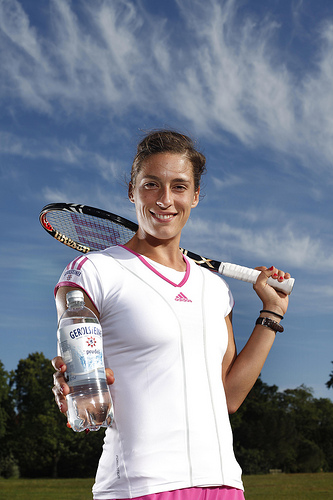Describe the outfit the person is wearing. The person is wearing a white sports shirt with a pink Adidas logo and stripes, along with what appears to be a matching pink sports skirt. The attire is appropriate for athletic endeavors, specifically tennis.  Can you comment on the type of water bottle the person is holding? The water bottle in the person's hand is clear, filled with water, and has a label that seems to indicate a brand, possibly suggesting a sponsorship or an endorsement. 